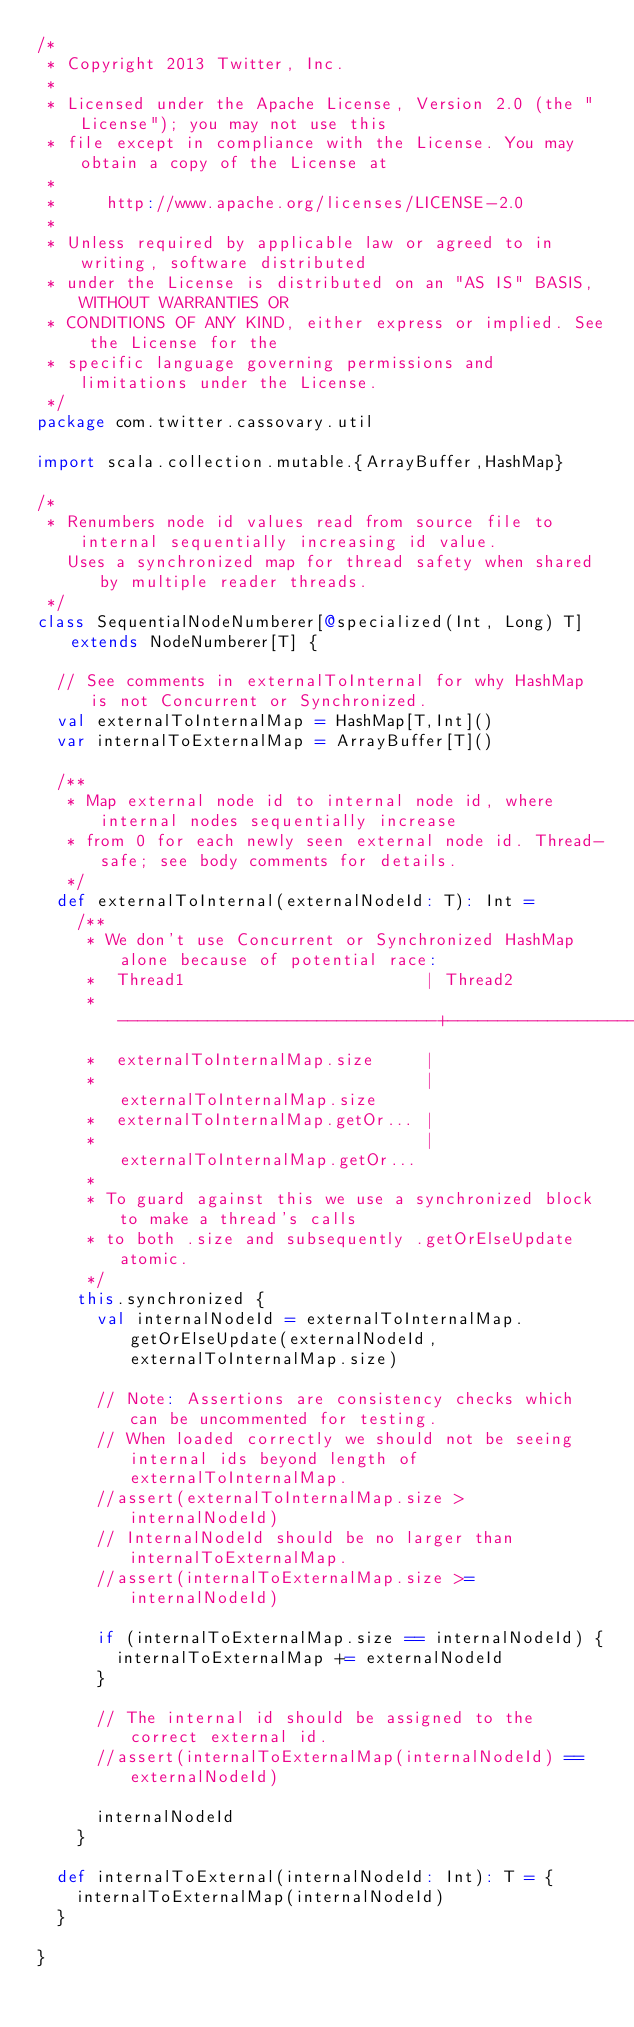Convert code to text. <code><loc_0><loc_0><loc_500><loc_500><_Scala_>/*
 * Copyright 2013 Twitter, Inc.
 *
 * Licensed under the Apache License, Version 2.0 (the "License"); you may not use this
 * file except in compliance with the License. You may obtain a copy of the License at
 *
 *     http://www.apache.org/licenses/LICENSE-2.0
 *
 * Unless required by applicable law or agreed to in writing, software distributed
 * under the License is distributed on an "AS IS" BASIS, WITHOUT WARRANTIES OR
 * CONDITIONS OF ANY KIND, either express or implied. See the License for the
 * specific language governing permissions and limitations under the License.
 */
package com.twitter.cassovary.util

import scala.collection.mutable.{ArrayBuffer,HashMap}

/*
 * Renumbers node id values read from source file to internal sequentially increasing id value.
   Uses a synchronized map for thread safety when shared by multiple reader threads.
 */
class SequentialNodeNumberer[@specialized(Int, Long) T] extends NodeNumberer[T] {

  // See comments in externalToInternal for why HashMap is not Concurrent or Synchronized.
  val externalToInternalMap = HashMap[T,Int]()
  var internalToExternalMap = ArrayBuffer[T]()

  /**
   * Map external node id to internal node id, where internal nodes sequentially increase
   * from 0 for each newly seen external node id. Thread-safe; see body comments for details.
   */
  def externalToInternal(externalNodeId: T): Int =
    /** 
     * We don't use Concurrent or Synchronized HashMap alone because of potential race:
     *  Thread1                        | Thread2
     * --------------------------------+------------------------
     *  externalToInternalMap.size     |
     *                                 |  externalToInternalMap.size
     *  externalToInternalMap.getOr... |
     *                                 |  externalToInternalMap.getOr...
     * 
     * To guard against this we use a synchronized block to make a thread's calls 
     * to both .size and subsequently .getOrElseUpdate atomic.
     */
    this.synchronized {
      val internalNodeId = externalToInternalMap.getOrElseUpdate(externalNodeId, externalToInternalMap.size)

      // Note: Assertions are consistency checks which can be uncommented for testing.
      // When loaded correctly we should not be seeing internal ids beyond length of externalToInternalMap.
      //assert(externalToInternalMap.size > internalNodeId)
      // InternalNodeId should be no larger than internalToExternalMap.
      //assert(internalToExternalMap.size >= internalNodeId)

      if (internalToExternalMap.size == internalNodeId) {
        internalToExternalMap += externalNodeId
      }

      // The internal id should be assigned to the correct external id.
      //assert(internalToExternalMap(internalNodeId) == externalNodeId)

      internalNodeId
    }

  def internalToExternal(internalNodeId: Int): T = {
    internalToExternalMap(internalNodeId)
  }

}
</code> 